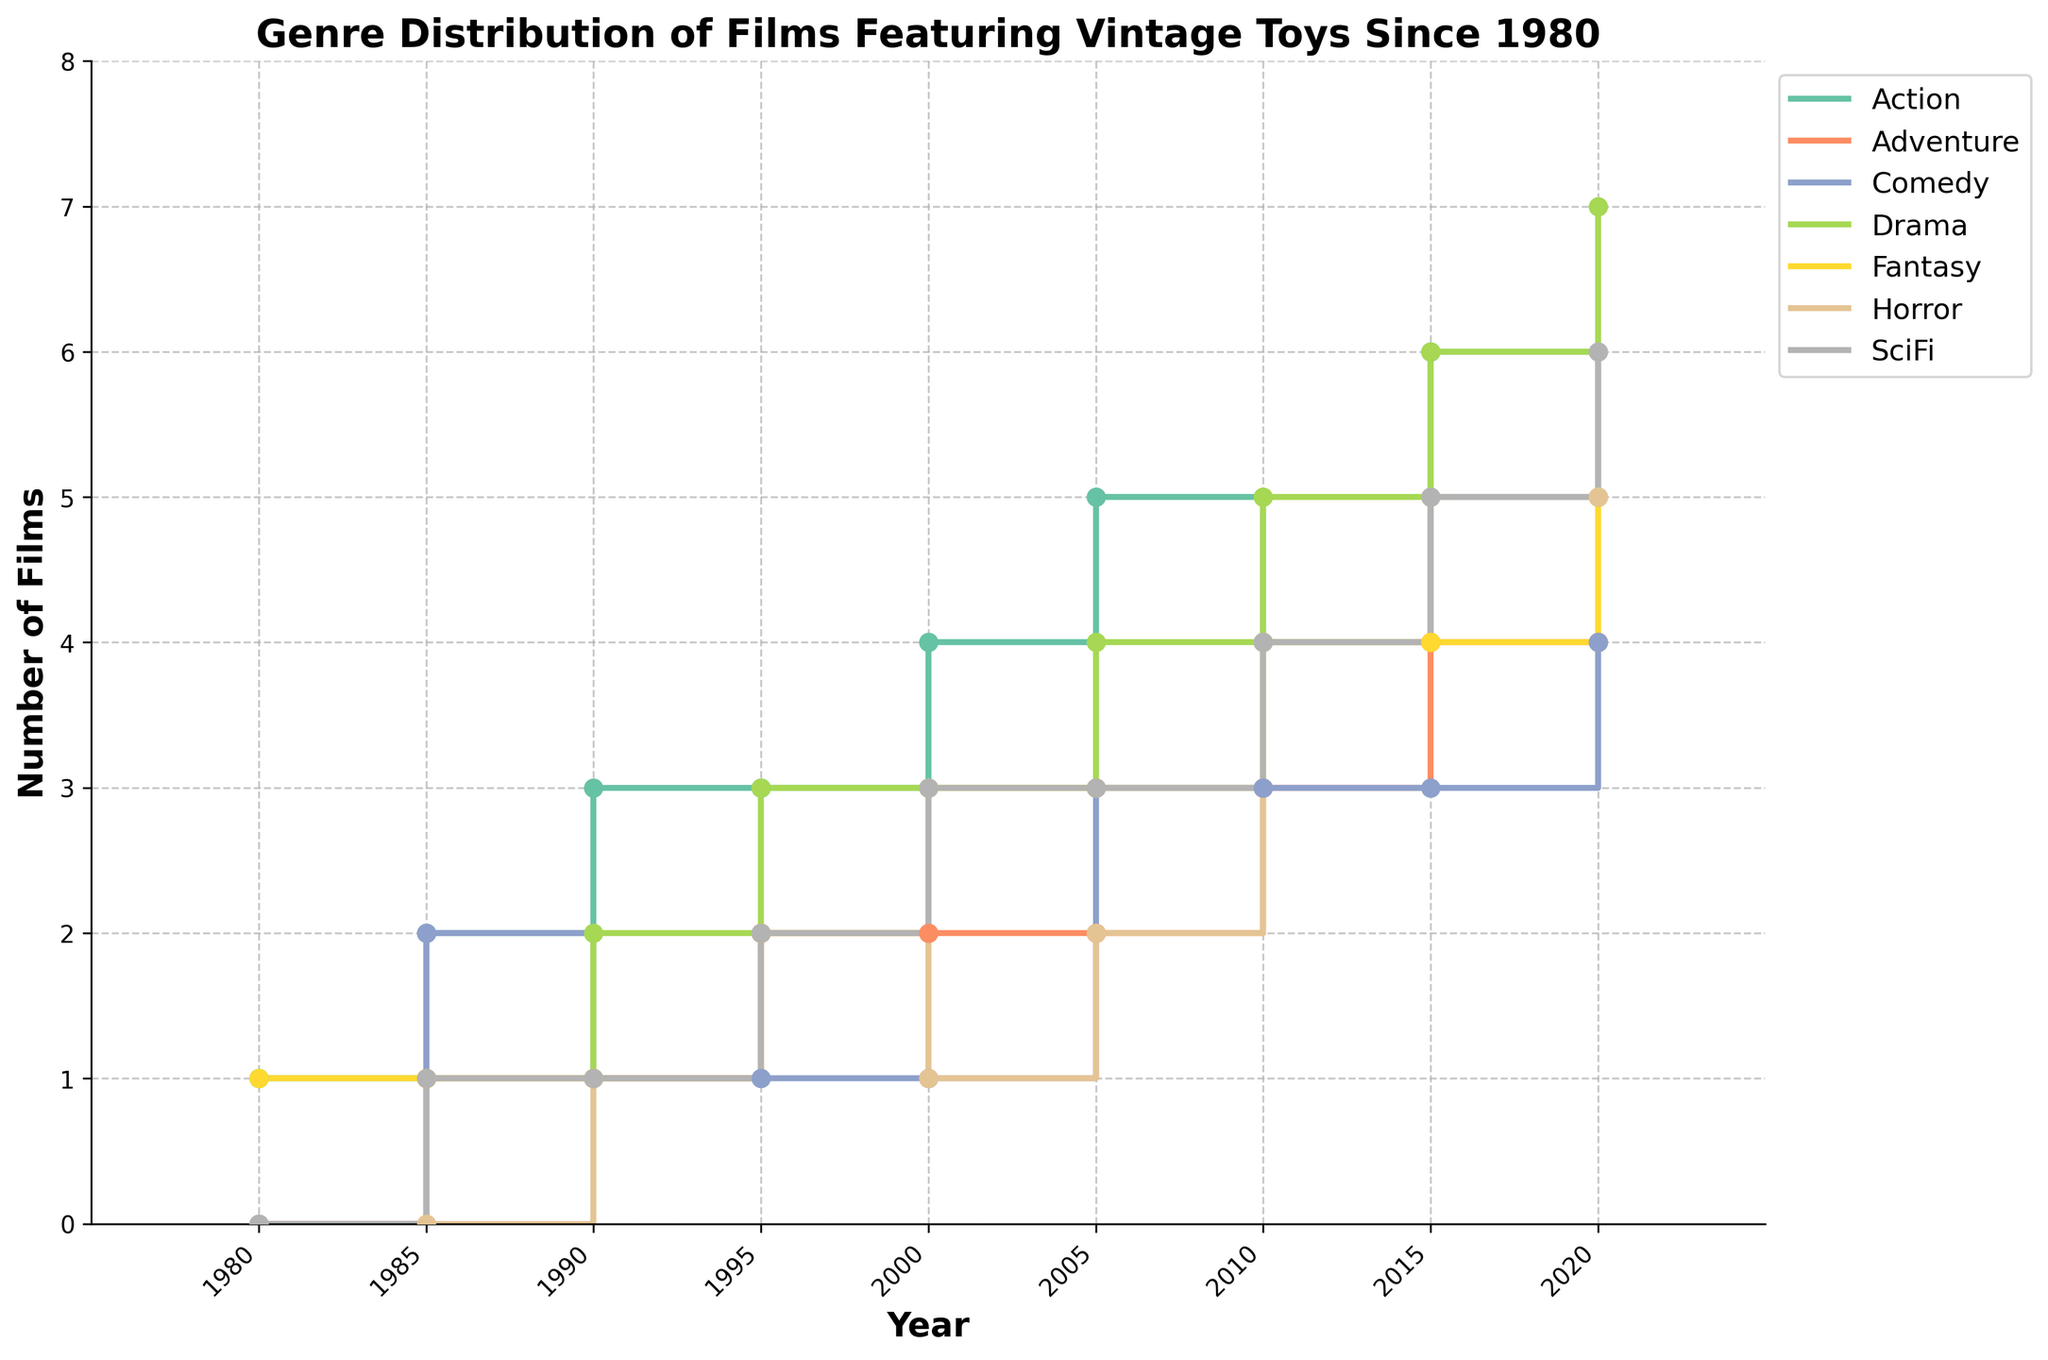What is the title of the plot? The title is usually displayed at the top of the plot. In this case, it's "Genre Distribution of Films Featuring Vintage Toys Since 1980".
Answer: Genre Distribution of Films Featuring Vintage Toys Since 1980 How many genres are depicted in the plot? Count the number of unique genres listed in the legend or the axis labels. In this case, there are seven genres: Action, Adventure, Comedy, Drama, Fantasy, Horror, and SciFi.
Answer: 7 What year had the highest number of Drama films? Look at the values for Drama over the years. The highest value occurs in 2020, with 7 films.
Answer: 2020 Which genre had the most films in 2005? Compare the values for each genre in the year 2005. The highest value is Drama with 4 films.
Answer: Drama How did the number of Action films change from 1980 to 2020? Find the values for Action in 1980 and 2020. In 1980, there was 1 Action film. In 2020, there were 5. The number increased by 4.
Answer: Increased by 4 Which genre saw the most significant increase from 1985 to 2020? Calculate the difference for each genre between 1985 and 2020. Science Fiction (SciFi) went from 1 in 1985 to 6 in 2020, an increase of 5, the highest among all genres.
Answer: SciFi In what year did Fantasy films first reach a count of 3? Look at the data points for Fantasy. The first instance of Fantasy reaching 3 films occurs in the year 2000.
Answer: 2000 Are there any genres that had the same number of films in both 2010 and 2015? Compare the values for each genre in the years 2010 and 2015. Both Comedy and Adventure had the same number of films (3) in these years.
Answer: Comedy, Adventure What was the trend for Horror films from 1995 to 2020? Observe the values for Horror films over these years. The trend shows a generally increasing pattern from 2 in 1995 to 5 in 2020.
Answer: Increasing Which genre had no films in 1980, but saw a continuous increase afterwards? Examine the initial values for each genre in 1980 and observe subsequent trends. Adventure had 0 films in 1980 but showed an increase in subsequent years.
Answer: Adventure 